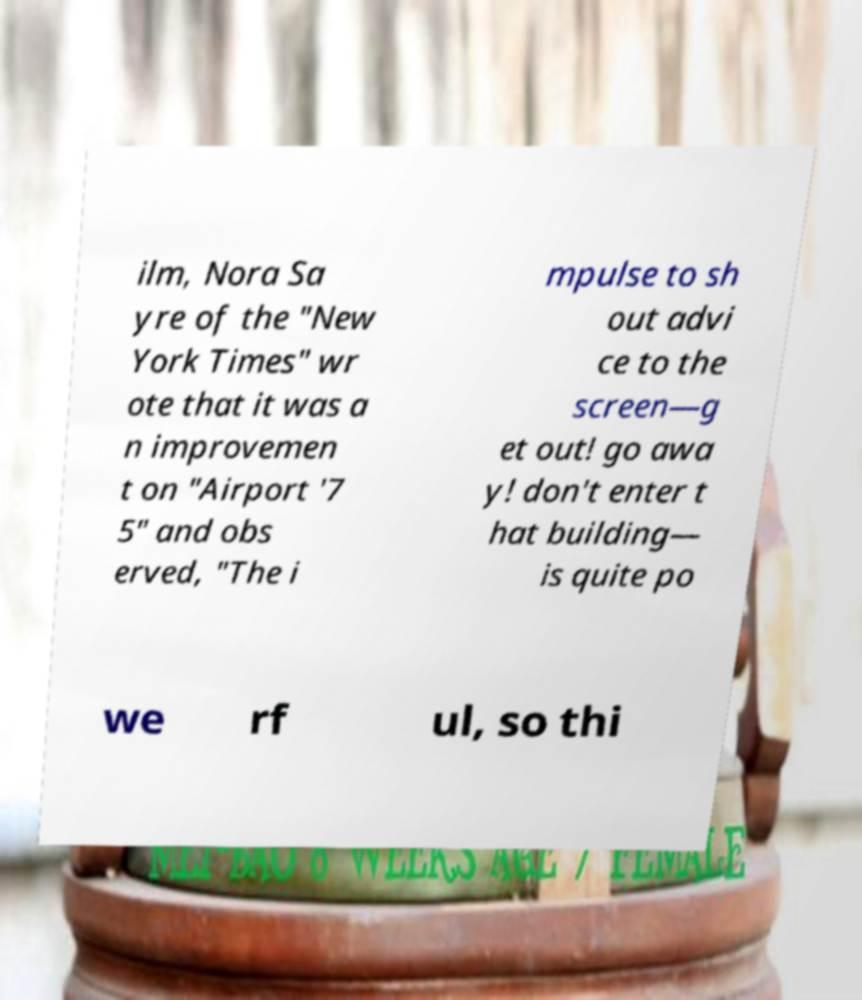Can you accurately transcribe the text from the provided image for me? ilm, Nora Sa yre of the "New York Times" wr ote that it was a n improvemen t on "Airport '7 5" and obs erved, "The i mpulse to sh out advi ce to the screen—g et out! go awa y! don't enter t hat building— is quite po we rf ul, so thi 